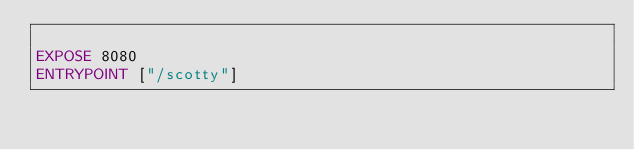Convert code to text. <code><loc_0><loc_0><loc_500><loc_500><_Dockerfile_>
EXPOSE 8080
ENTRYPOINT ["/scotty"]
</code> 